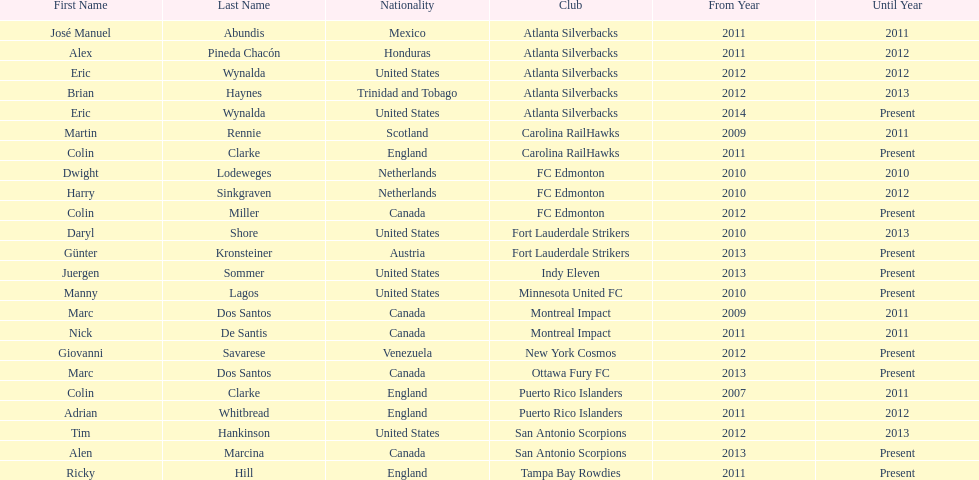How many total coaches on the list are from canada? 5. 